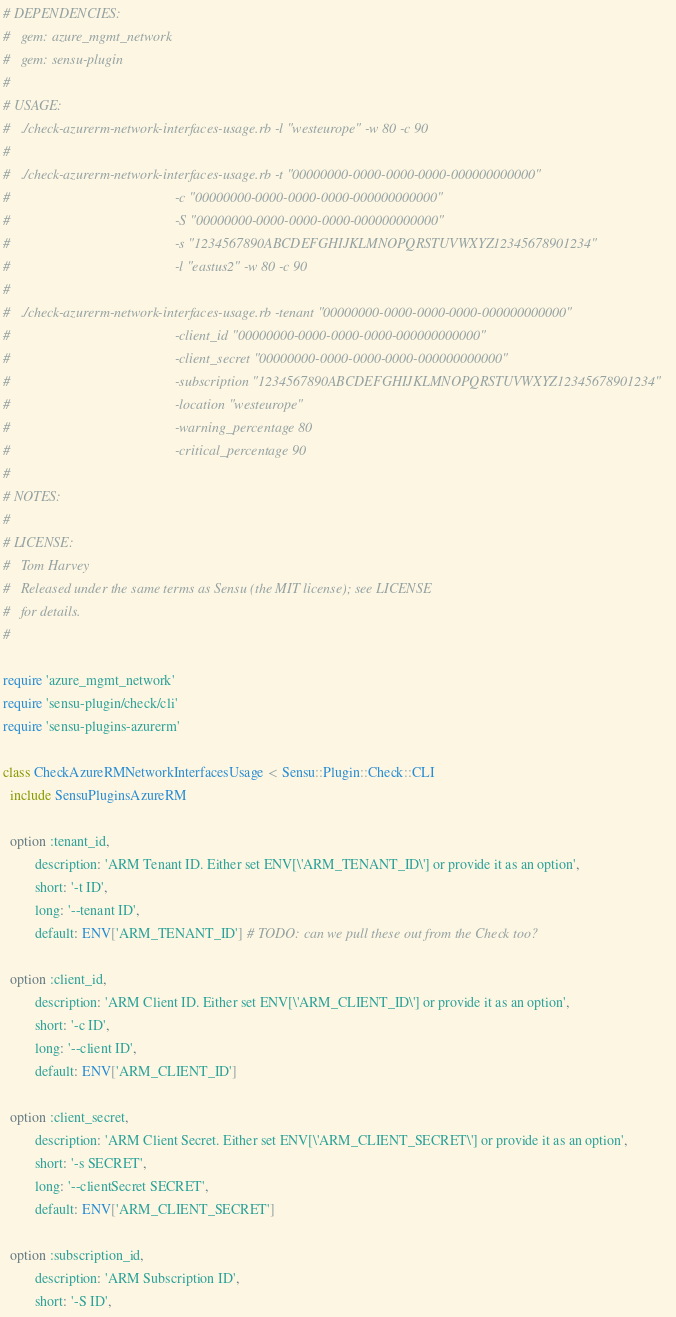<code> <loc_0><loc_0><loc_500><loc_500><_Ruby_># DEPENDENCIES:
#   gem: azure_mgmt_network
#   gem: sensu-plugin
#
# USAGE:
#   ./check-azurerm-network-interfaces-usage.rb -l "westeurope" -w 80 -c 90
#
#   ./check-azurerm-network-interfaces-usage.rb -t "00000000-0000-0000-0000-000000000000"
#                                               -c "00000000-0000-0000-0000-000000000000"
#                                               -S "00000000-0000-0000-0000-000000000000"
#                                               -s "1234567890ABCDEFGHIJKLMNOPQRSTUVWXYZ12345678901234"
#                                               -l "eastus2" -w 80 -c 90
#
#   ./check-azurerm-network-interfaces-usage.rb -tenant "00000000-0000-0000-0000-000000000000"
#                                               -client_id "00000000-0000-0000-0000-000000000000"
#                                               -client_secret "00000000-0000-0000-0000-000000000000"
#                                               -subscription "1234567890ABCDEFGHIJKLMNOPQRSTUVWXYZ12345678901234"
#                                               -location "westeurope"
#                                               -warning_percentage 80
#                                               -critical_percentage 90
#
# NOTES:
#
# LICENSE:
#   Tom Harvey
#   Released under the same terms as Sensu (the MIT license); see LICENSE
#   for details.
#

require 'azure_mgmt_network'
require 'sensu-plugin/check/cli'
require 'sensu-plugins-azurerm'

class CheckAzureRMNetworkInterfacesUsage < Sensu::Plugin::Check::CLI
  include SensuPluginsAzureRM

  option :tenant_id,
         description: 'ARM Tenant ID. Either set ENV[\'ARM_TENANT_ID\'] or provide it as an option',
         short: '-t ID',
         long: '--tenant ID',
         default: ENV['ARM_TENANT_ID'] # TODO: can we pull these out from the Check too?

  option :client_id,
         description: 'ARM Client ID. Either set ENV[\'ARM_CLIENT_ID\'] or provide it as an option',
         short: '-c ID',
         long: '--client ID',
         default: ENV['ARM_CLIENT_ID']

  option :client_secret,
         description: 'ARM Client Secret. Either set ENV[\'ARM_CLIENT_SECRET\'] or provide it as an option',
         short: '-s SECRET',
         long: '--clientSecret SECRET',
         default: ENV['ARM_CLIENT_SECRET']

  option :subscription_id,
         description: 'ARM Subscription ID',
         short: '-S ID',</code> 